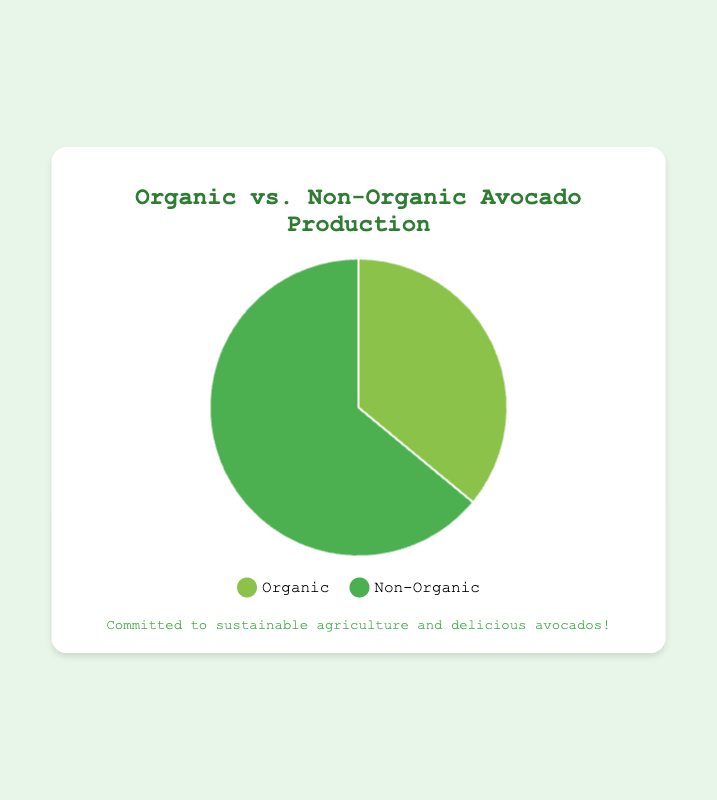What percentage of avocado production is organic? The chart shows two categories, Organic (36%) and Non-Organic (64%). The percentage for Organic is explicitly marked as 36%.
Answer: 36% What is the difference in percentage between Organic and Non-Organic avocado production? The chart shows that Non-Organic production is 64% and Organic production is 36%. The difference can be calculated as 64% - 36% = 28%.
Answer: 28% Which type of avocado production is more prevalent? The chart shows Non-Organic production at 64% and Organic production at 36%. Non-Organic production has a higher percentage.
Answer: Non-Organic By how much does Non-Organic avocado production exceed Organic avocado production? Non-Organic production is 64% and Organic production is 36%. The exceedance is calculated as 64% - 36% = 28%.
Answer: 28% If the total avocado production is 100,000 lbs, how many pounds are produced organically? Given that 36% of avocado production is organic, we calculate the weight as 0.36 * 100,000 lbs = 36,000 lbs.
Answer: 36,000 lbs If the total avocado production is 100,000 lbs, how many pounds are non-organic? Non-Organic production accounts for 64%. Therefore, 0.64 * 100,000 lbs = 64,000 lbs.
Answer: 64,000 lbs What colors represent Organic and Non-Organic avocado production in the chart? The chart legend shows that Organic avocados are represented by a light green color, while Non-Organic avocados are shown in a darker green.
Answer: light green for Organic, dark green for Non-Organic 